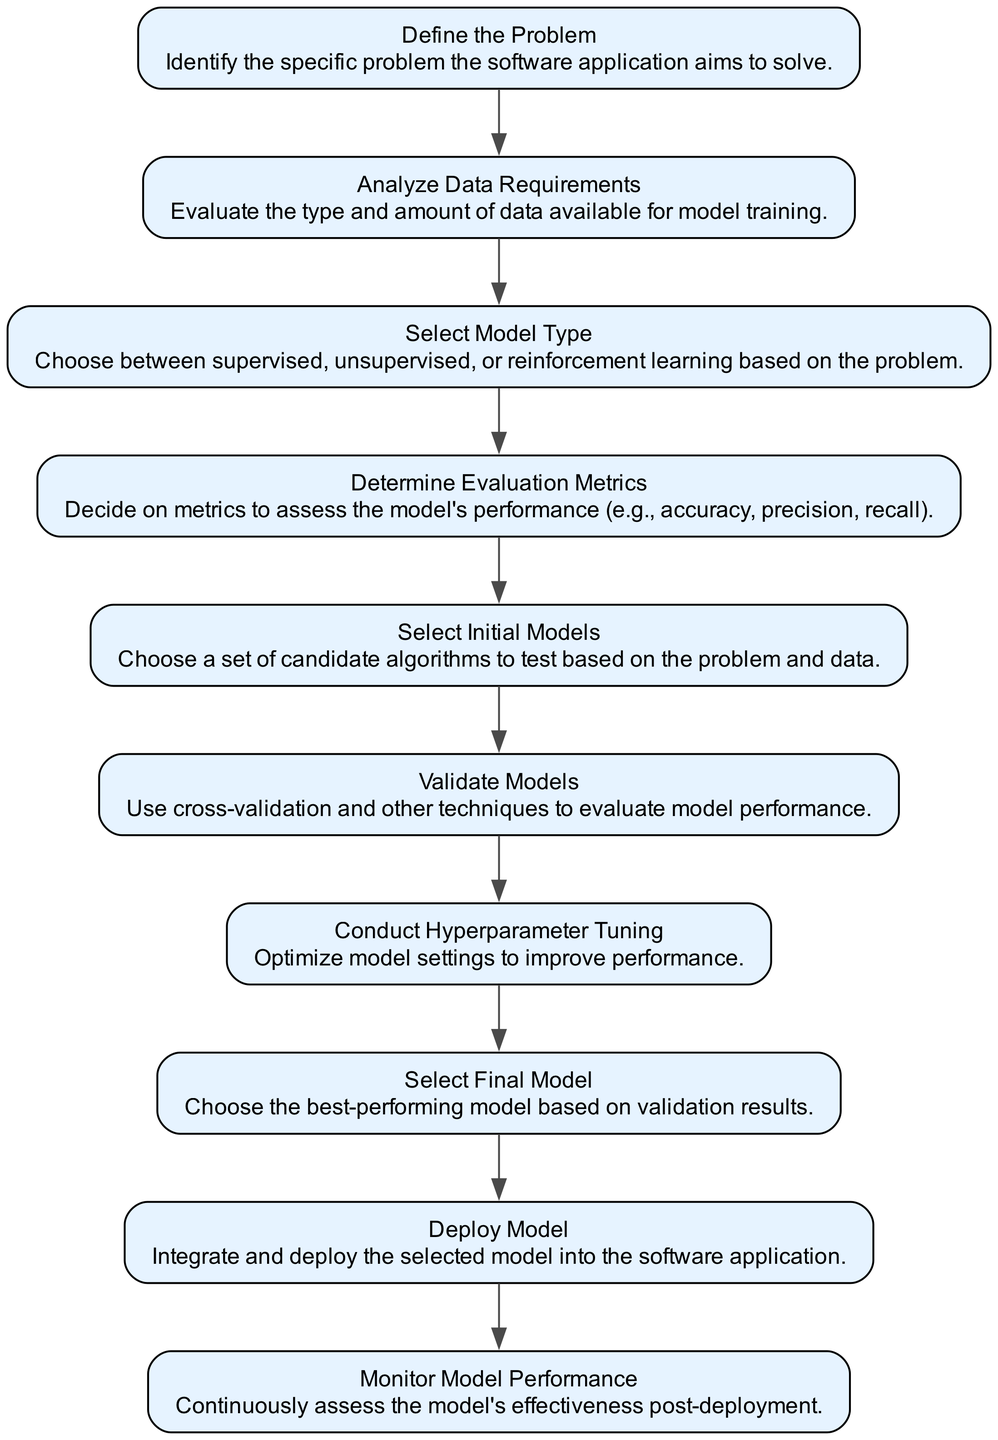What is the first step in the decision-making process? The flow chart starts with the "Define the Problem" node, indicating it as the initial step to identify the specific problem the software application aims to solve.
Answer: Define the Problem How many nodes are present in the diagram? By counting the individual steps, we find there are ten nodes, including their labels and descriptions related to the machine learning model selection process.
Answer: Ten What type of learning models might be selected after analyzing data requirements? Following the "Analyze Data Requirements" step, the next step is "Select Model Type," where the choice of supervised, unsupervised, or reinforcement learning is made based on the problem identified.
Answer: Model Type What do you determine during the "Determine Evaluation Metrics" stage? This step allows you to decide on specific performance metrics to assess how well the machine learning model is performing, such as accuracy, precision, or recall.
Answer: Evaluation Metrics What step follows after "Select Initial Models"? Once initial models are selected, the next logical step in the flow chart is "Validate Models," where these candidate algorithms will be tested and evaluated for performance.
Answer: Validate Models What is the last step before deploying the model? Before deploying the model, the final stage is "Select Final Model," where the best-performing model is chosen based on the results of previous evaluations to ensure effectiveness.
Answer: Select Final Model What connects "Conduct Hyperparameter Tuning" and "Select Final Model"? The arrow connecting these two steps signifies that after tuning the hyperparameters to optimize the model, the next action is to select the final model based on improved performance.
Answer: An arrow (connection) Which step is crucial for ongoing assessment after deployment? The last step in the flow chart emphasizes the need for "Monitor Model Performance," allowing for continuous assessment of the model's effectiveness after it has been deployed.
Answer: Monitor Model Performance What directs the flow from the analysis of data requirements? The flow proceeds from "Analyze Data Requirements" to "Select Model Type," meaning that data evaluation directly influences the type of machine learning approach chosen.
Answer: An arrow (connection) 